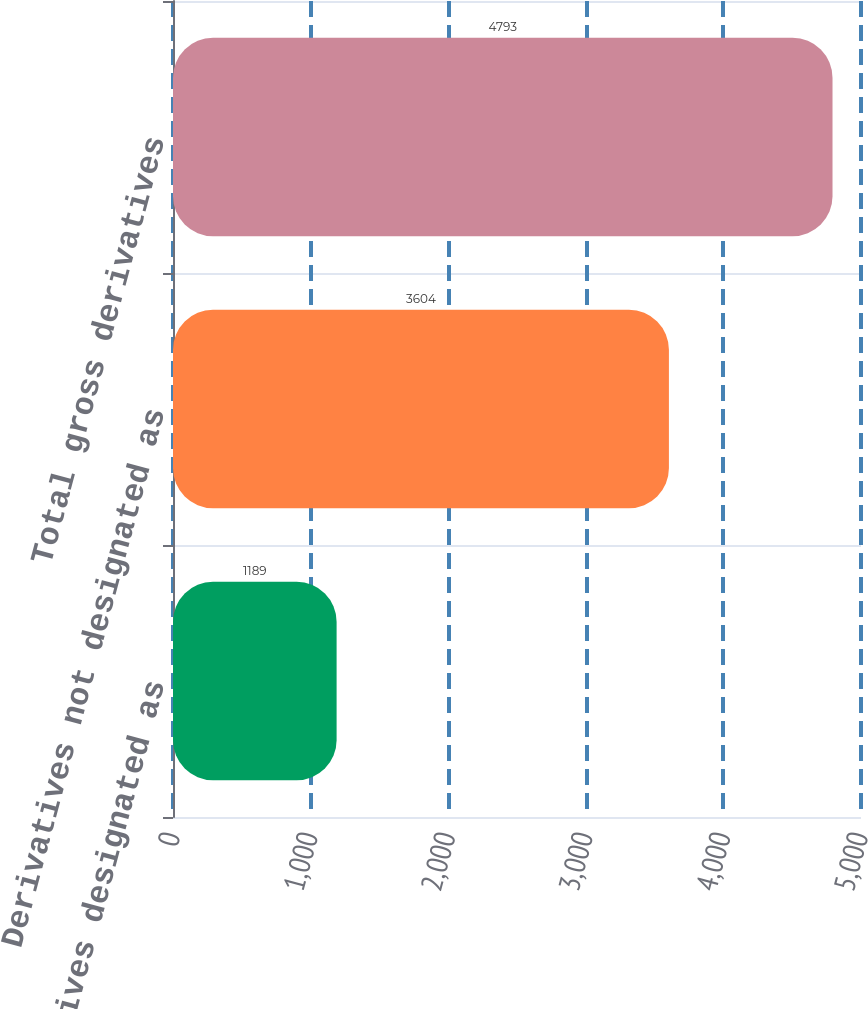<chart> <loc_0><loc_0><loc_500><loc_500><bar_chart><fcel>Derivatives designated as<fcel>Derivatives not designated as<fcel>Total gross derivatives<nl><fcel>1189<fcel>3604<fcel>4793<nl></chart> 